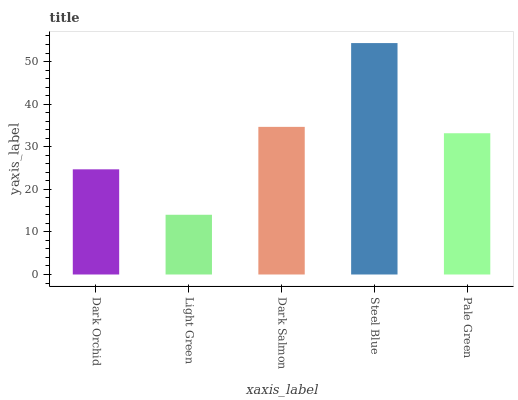Is Light Green the minimum?
Answer yes or no. Yes. Is Steel Blue the maximum?
Answer yes or no. Yes. Is Dark Salmon the minimum?
Answer yes or no. No. Is Dark Salmon the maximum?
Answer yes or no. No. Is Dark Salmon greater than Light Green?
Answer yes or no. Yes. Is Light Green less than Dark Salmon?
Answer yes or no. Yes. Is Light Green greater than Dark Salmon?
Answer yes or no. No. Is Dark Salmon less than Light Green?
Answer yes or no. No. Is Pale Green the high median?
Answer yes or no. Yes. Is Pale Green the low median?
Answer yes or no. Yes. Is Dark Orchid the high median?
Answer yes or no. No. Is Steel Blue the low median?
Answer yes or no. No. 